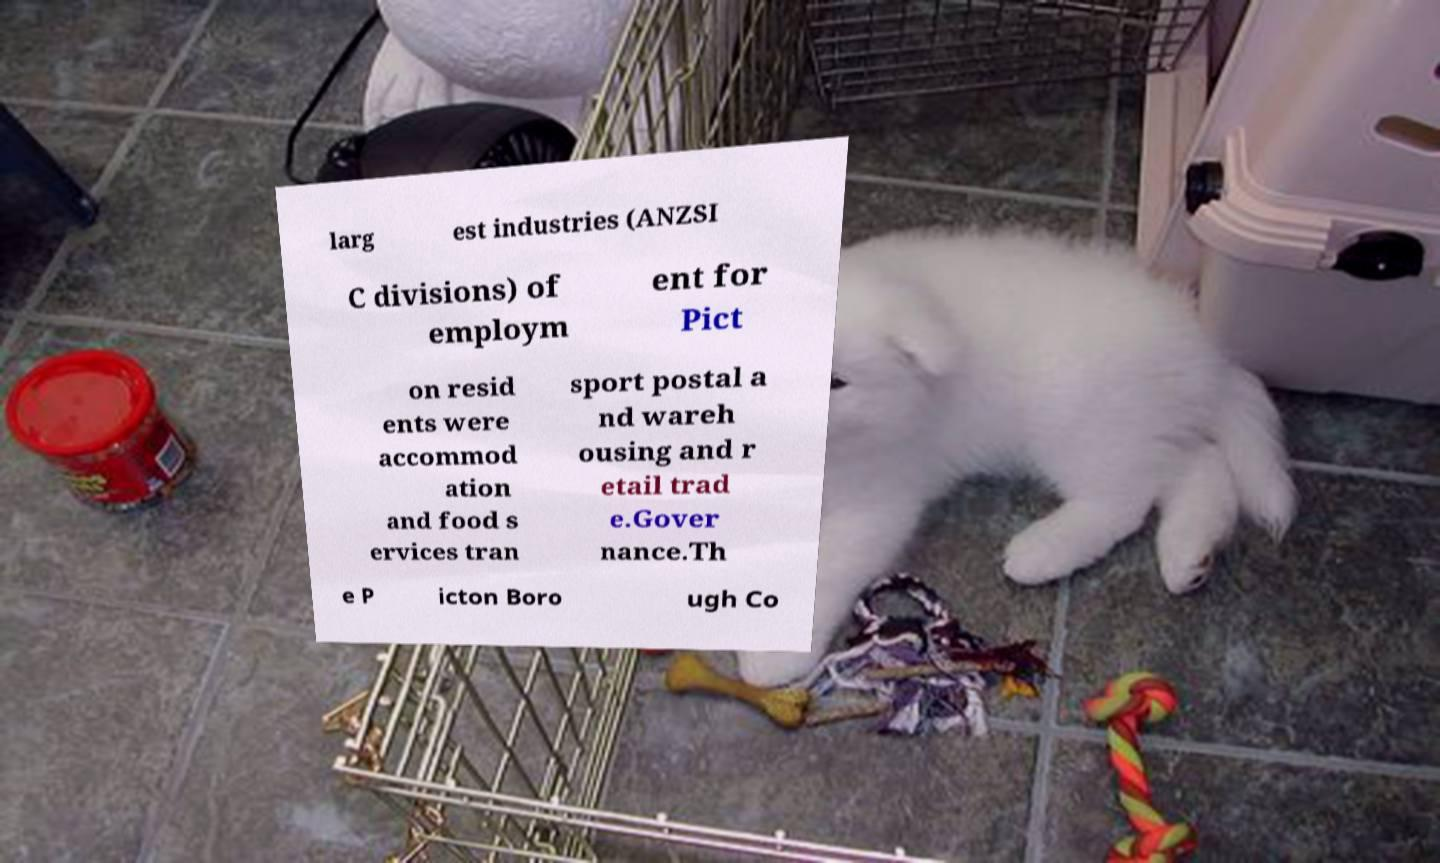For documentation purposes, I need the text within this image transcribed. Could you provide that? larg est industries (ANZSI C divisions) of employm ent for Pict on resid ents were accommod ation and food s ervices tran sport postal a nd wareh ousing and r etail trad e.Gover nance.Th e P icton Boro ugh Co 